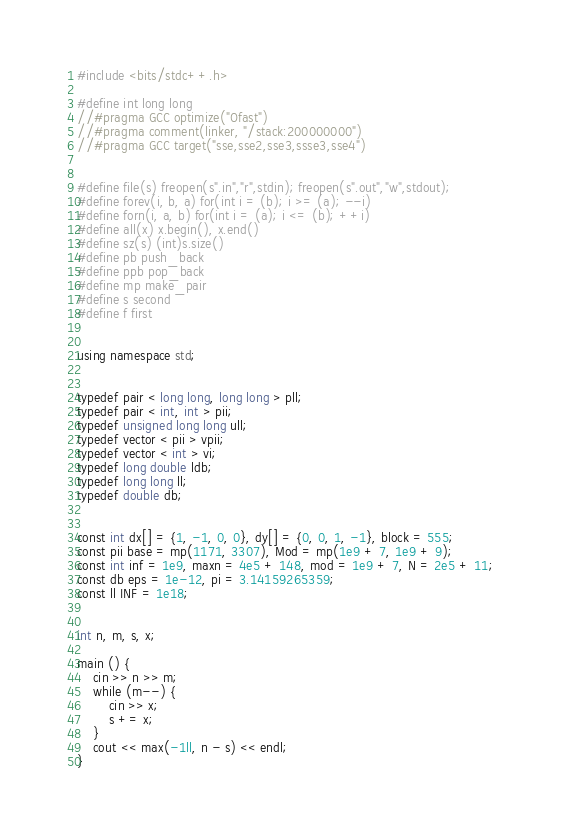<code> <loc_0><loc_0><loc_500><loc_500><_C++_>#include <bits/stdc++.h>                                           
 
#define int long long
//#pragma GCC optimize("Ofast")
//#pragma comment(linker, "/stack:200000000")
//#pragma GCC target("sse,sse2,sse3,ssse3,sse4")
 
 
#define file(s) freopen(s".in","r",stdin); freopen(s".out","w",stdout);
#define forev(i, b, a) for(int i = (b); i >= (a); --i)
#define forn(i, a, b) for(int i = (a); i <= (b); ++i)
#define all(x) x.begin(), x.end()
#define sz(s) (int)s.size()
#define pb push_back
#define ppb pop_back
#define mp make_pair
#define s second
#define f first
 
 
using namespace std;
 
 
typedef pair < long long, long long > pll;    
typedef pair < int, int > pii;
typedef unsigned long long ull;         
typedef vector < pii > vpii;
typedef vector < int > vi;
typedef long double ldb;  
typedef long long ll;  
typedef double db;                             
 
 
const int dx[] = {1, -1, 0, 0}, dy[] = {0, 0, 1, -1}, block = 555;
const pii base = mp(1171, 3307), Mod = mp(1e9 + 7, 1e9 + 9);
const int inf = 1e9, maxn = 4e5 + 148, mod = 1e9 + 7, N = 2e5 + 11;
const db eps = 1e-12, pi = 3.14159265359;
const ll INF = 1e18;


int n, m, s, x;

main () {
	cin >> n >> m;
	while (m--) {
		cin >> x;
		s += x;
	}
	cout << max(-1ll, n - s) << endl;
}
</code> 